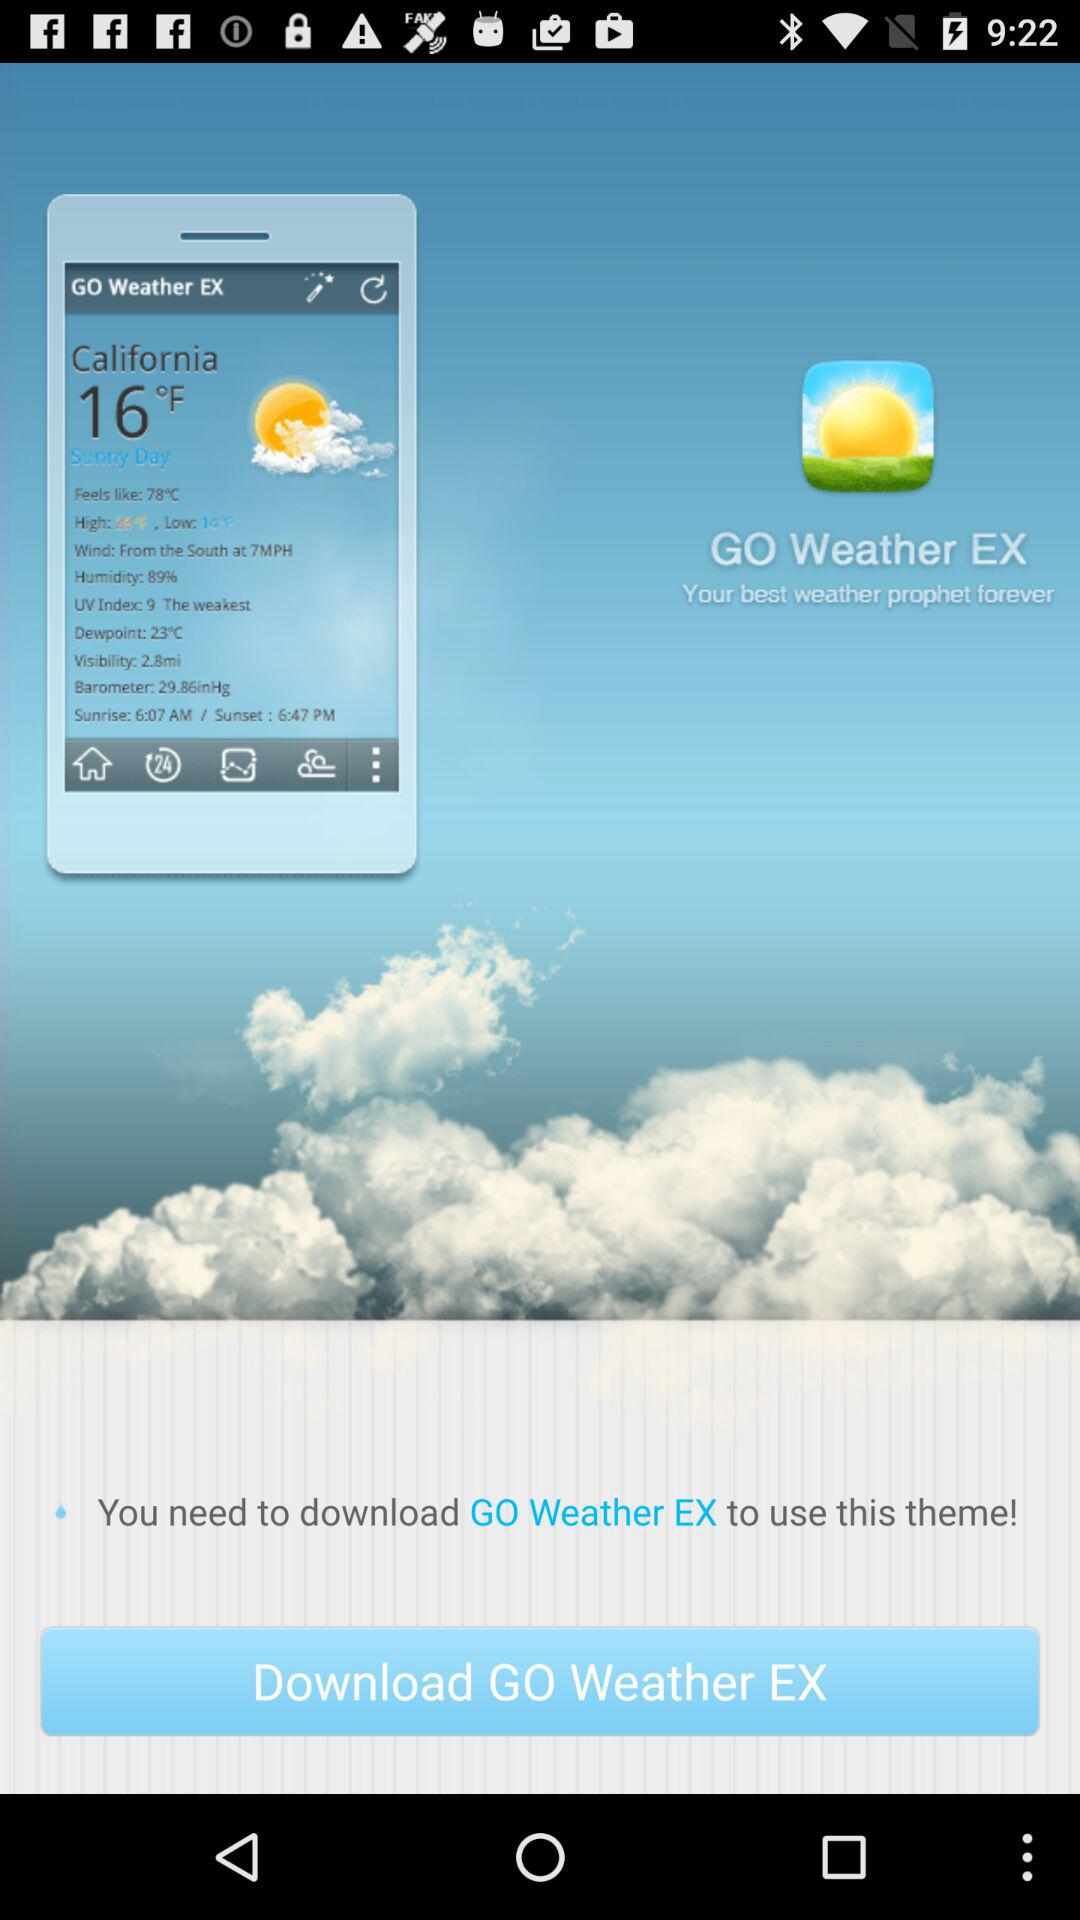In California, what is the visibility? The visibility in California is 2.8 miles. 